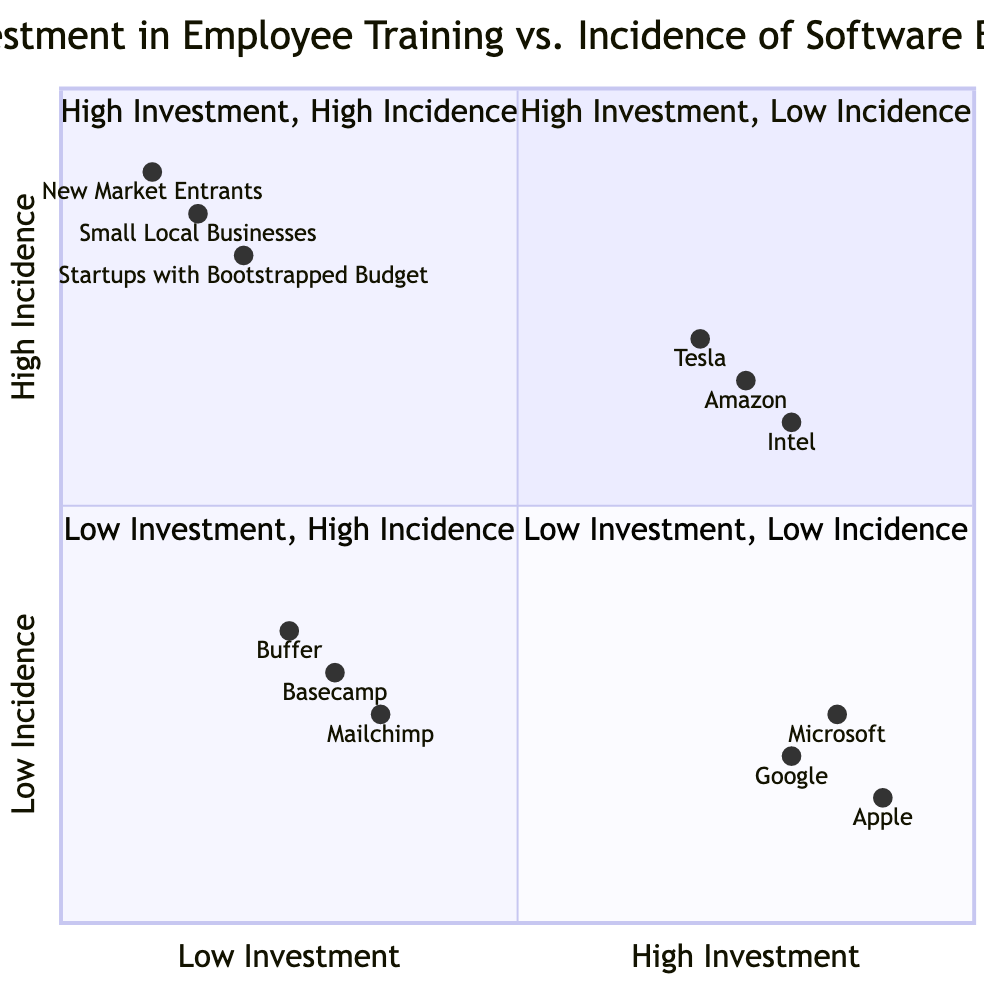What companies are in the High Investment, Low Incidence quadrant? The High Investment, Low Incidence quadrant contains companies that invest heavily in employee training and tend to have fewer software bugs. The examples provided are Google, Microsoft, and Apple.
Answer: Google, Microsoft, Apple Which quadrant contains companies with high incidence of software bugs and high investment in employee training? The quadrant that describes companies with high incidence of software bugs despite high investment in employee training is the High Investment, High Incidence quadrant. The examples listed are Tesla, Amazon, and Intel.
Answer: High Investment, High Incidence How many companies are placed in the Low Investment, Low Incidence quadrant? The Low Investment, Low Incidence quadrant includes companies that invest minimally in employee training and maintain low software bug rates. The companies listed here are Basecamp, Buffer, and Mailchimp, totaling three.
Answer: Three What is the primary characteristic of companies in the Low Investment, High Incidence quadrant? Companies in the Low Investment, High Incidence quadrant typically have low investment in employee training and experience a high incidence of software bugs. The key trait is low training investment leading to more bugs.
Answer: Low training investment, high bugs Which company has the highest investment in employee training among the listed examples? Among the listed companies, Apple exhibits the highest investment in employee training, as indicated by its position towards the far right of the x-axis. The x-axis represents employee training investment, and Apple is at 0.9.
Answer: Apple Which quadrant has companies like Tesla and Amazon? Tesla and Amazon are located in the quadrant that reflects high investment in employee training yet high incidence of software bugs. This categorization suggests that these companies face challenges despite their training investments.
Answer: High Investment, High Incidence What is the incidence of software bugs for companies in the Low Investment, Low Incidence quadrant? The companies located in the Low Investment, Low Incidence quadrant, such as Basecamp, Buffer, and Mailchimp, exhibit low incidence rates of software bugs, with values like 0.3, 0.35, and 0.25 respectively. The pattern suggests very few bugs.
Answer: Low incidence How does the incidence of software bugs compare between High Investment, Low Incidence and Low Investment, High Incidence quadrants? The High Investment, Low Incidence quadrant, such as that of Google, shows low software bug incidence (around 0.2 or lower). In contrast, the Low Investment, High Incidence quadrant (like Startups) demonstrates significantly higher incidence rates (often above 0.8). This comparison highlights a direct contrast.
Answer: Lower in High Investment, Low Incidence Which company exhibits the lowest incidence of software bugs? Among all the examples, the company exhibiting the lowest incidence of software bugs is Apple, with a value of 0.15, placing it in the High Investment, Low Incidence quadrant.
Answer: Apple 